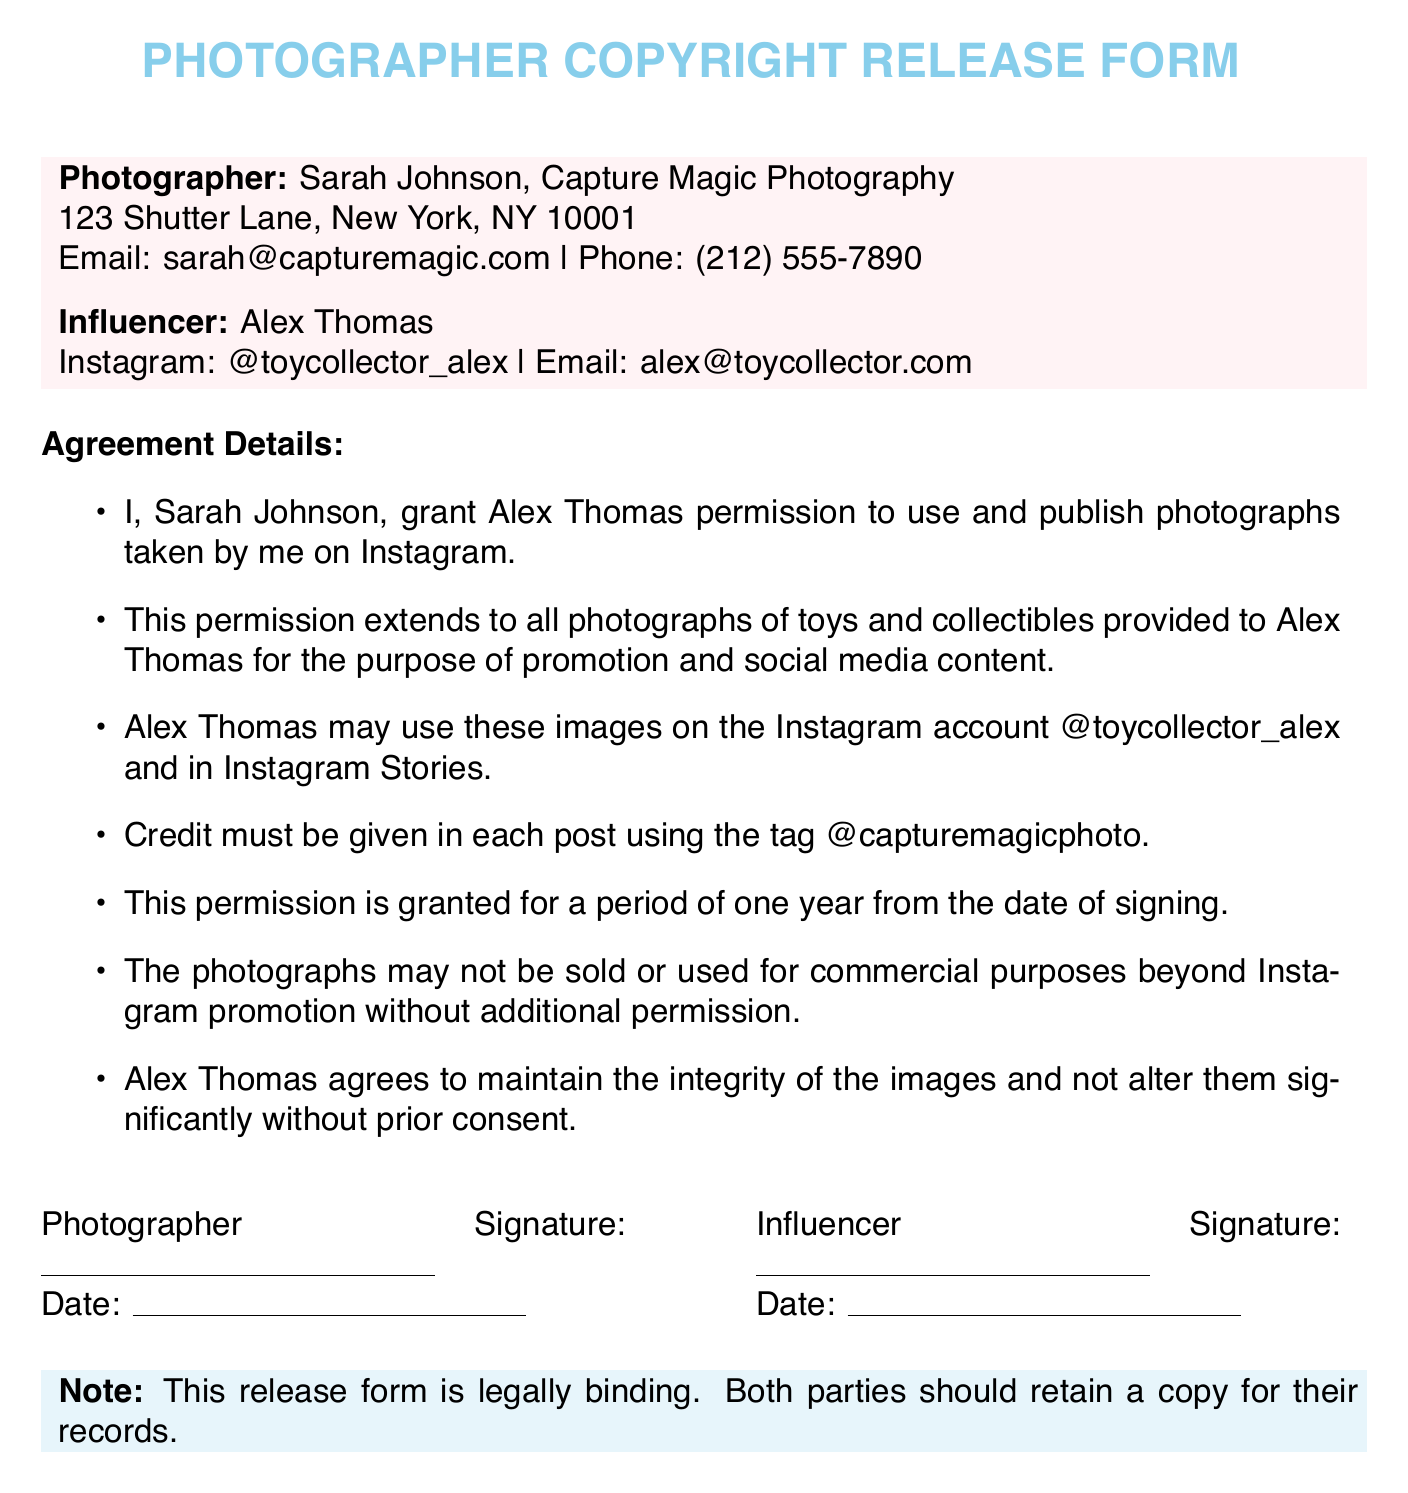What is the name of the photographer? The photographer is mentioned as Sarah Johnson, who represents Capture Magic Photography.
Answer: Sarah Johnson What is the email address of the photographer? The document specifies the email address for the photographer as provided in the contact section.
Answer: sarah@capturemagic.com Who is the influencer mentioned in the document? The document states the name of the influencer who will feature the photographs.
Answer: Alex Thomas What is the Instagram handle of the influencer? The influencer's Instagram handle is provided along with their other details.
Answer: @toycollector_alex For how long is the permission granted? The document specifies the duration of the permission granted for the use of photographs.
Answer: one year What must be included in each post featuring the photographs? The document outlines that credit must be given and specifies the required tag format to accompany the posts.
Answer: @capturemagicphoto Are the photographs permitted to be sold? The document clearly states the restrictions on the use of the photographs in terms of selling or commercial usage.
Answer: No What type of modifications to the images are allowed without prior consent? The document mentions the nature of alterations that Alex Thomas must avoid without obtaining prior consent.
Answer: significant alterations What is the nature of the note at the bottom of the document? The note emphasizes an important aspect of the copyright release form related to its legal status.
Answer: legally binding 